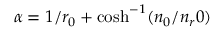<formula> <loc_0><loc_0><loc_500><loc_500>\alpha = 1 / r _ { 0 } + \cosh ^ { - 1 } ( n _ { 0 } / n _ { r } 0 )</formula> 